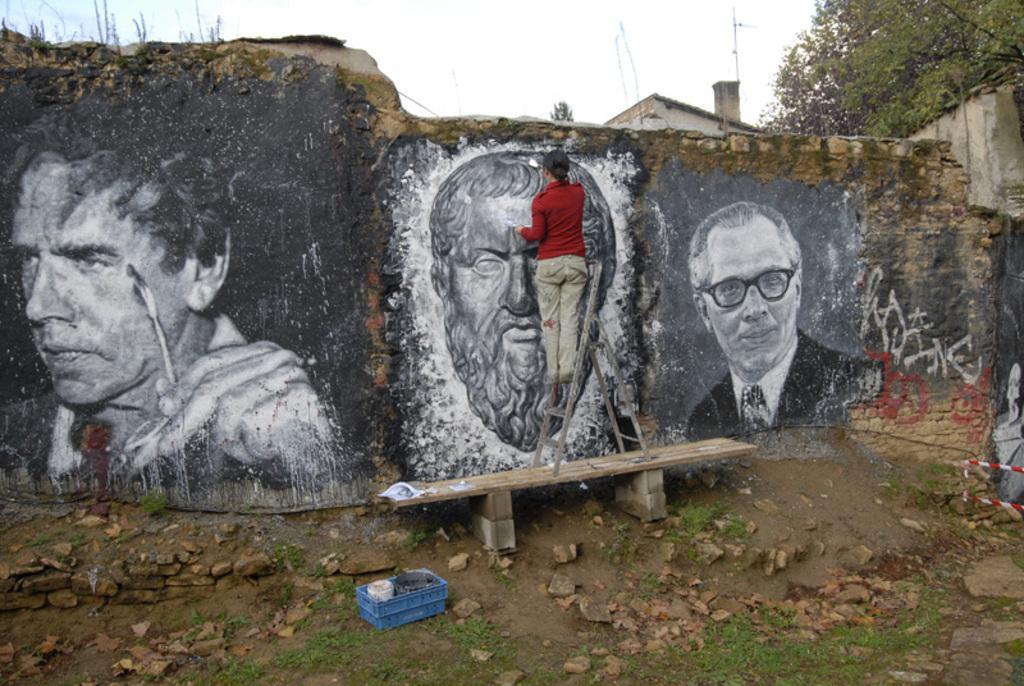In one or two sentences, can you explain what this image depicts? Above this bench there is a ladder. This person is standing on ladder, holding a paintbrush and painting on this wall. On this surface there is a container. Background there are trees and sky.  